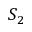Convert formula to latex. <formula><loc_0><loc_0><loc_500><loc_500>S _ { 2 }</formula> 